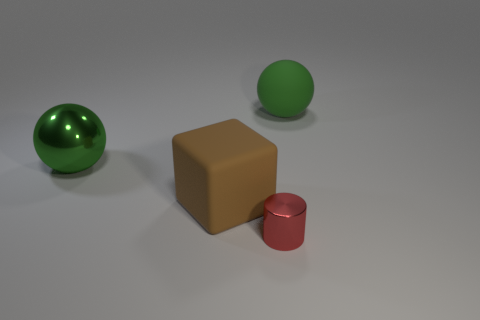Add 2 red metal cylinders. How many objects exist? 6 Subtract all cylinders. How many objects are left? 3 Add 4 cubes. How many cubes exist? 5 Subtract 0 purple blocks. How many objects are left? 4 Subtract all brown rubber spheres. Subtract all big things. How many objects are left? 1 Add 2 shiny balls. How many shiny balls are left? 3 